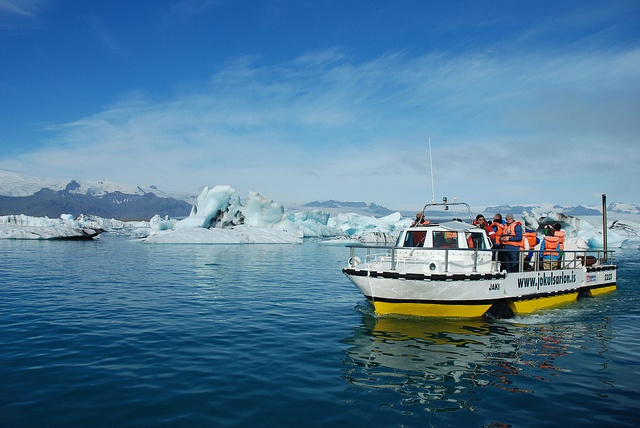Describe the objects in this image and their specific colors. I can see boat in gray, lightgray, black, and darkgray tones, people in gray, black, navy, darkblue, and maroon tones, people in gray, black, blue, and salmon tones, people in gray, black, red, brown, and maroon tones, and people in gray, red, navy, black, and brown tones in this image. 